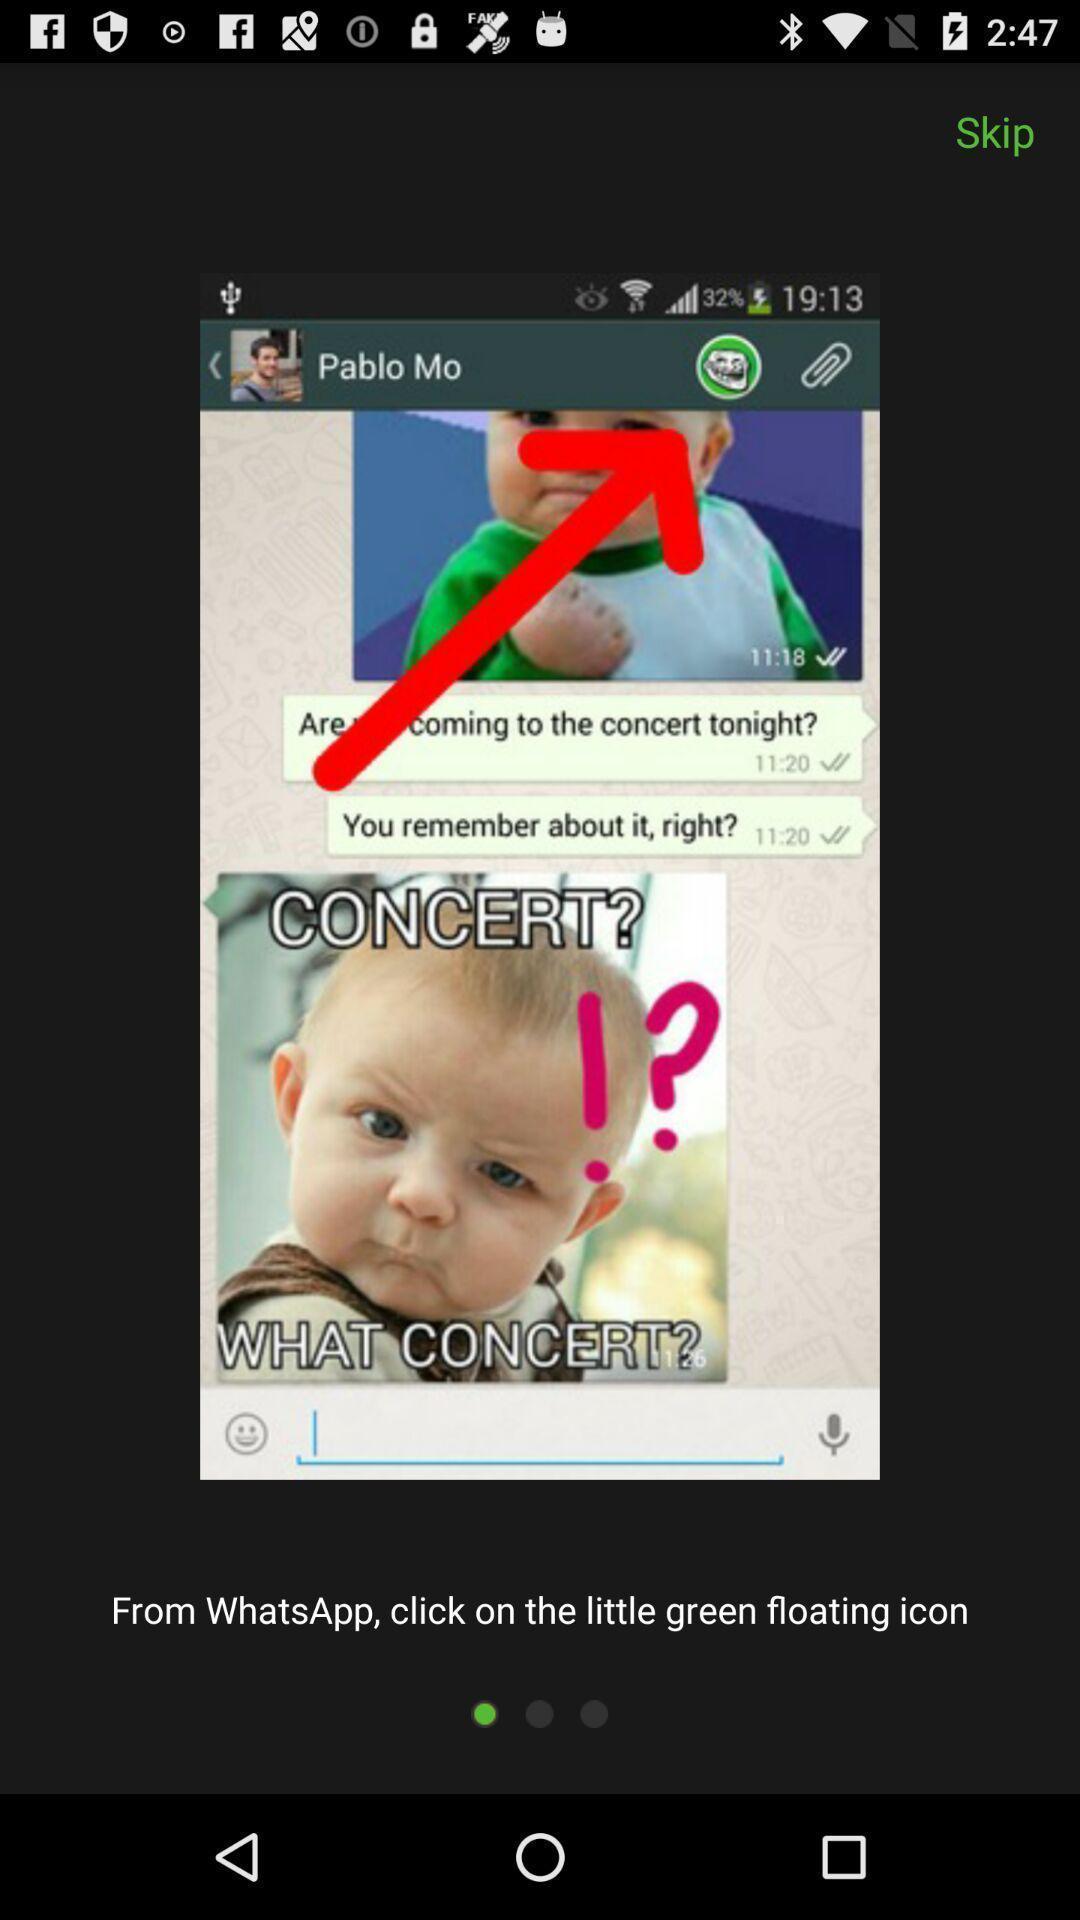Describe this image in words. Screen showing chat page in a social media app. 